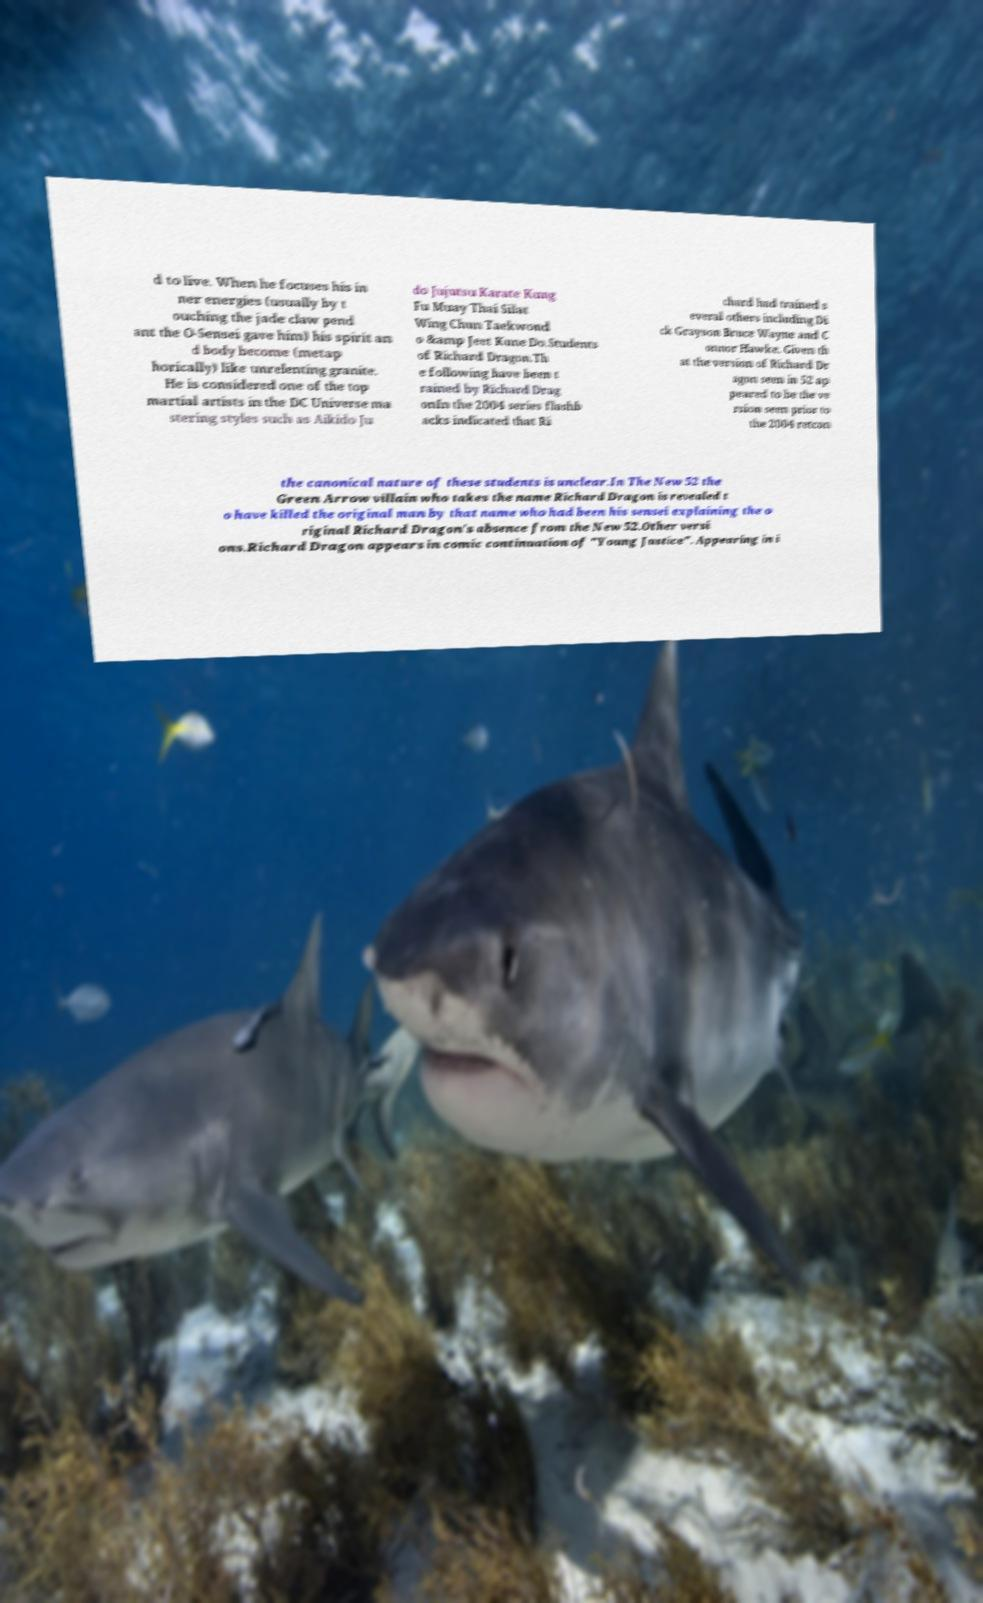Can you accurately transcribe the text from the provided image for me? d to live. When he focuses his in ner energies (usually by t ouching the jade claw pend ant the O-Sensei gave him) his spirit an d body become (metap horically) like unrelenting granite. He is considered one of the top martial artists in the DC Universe ma stering styles such as Aikido Ju do Jujutsu Karate Kung Fu Muay Thai Silat Wing Chun Taekwond o &amp Jeet Kune Do.Students of Richard Dragon.Th e following have been t rained by Richard Drag onIn the 2004 series flashb acks indicated that Ri chard had trained s everal others including Di ck Grayson Bruce Wayne and C onnor Hawke. Given th at the version of Richard Dr agon seen in 52 ap peared to be the ve rsion seen prior to the 2004 retcon the canonical nature of these students is unclear.In The New 52 the Green Arrow villain who takes the name Richard Dragon is revealed t o have killed the original man by that name who had been his sensei explaining the o riginal Richard Dragon's absence from the New 52.Other versi ons.Richard Dragon appears in comic continuation of "Young Justice". Appearing in i 